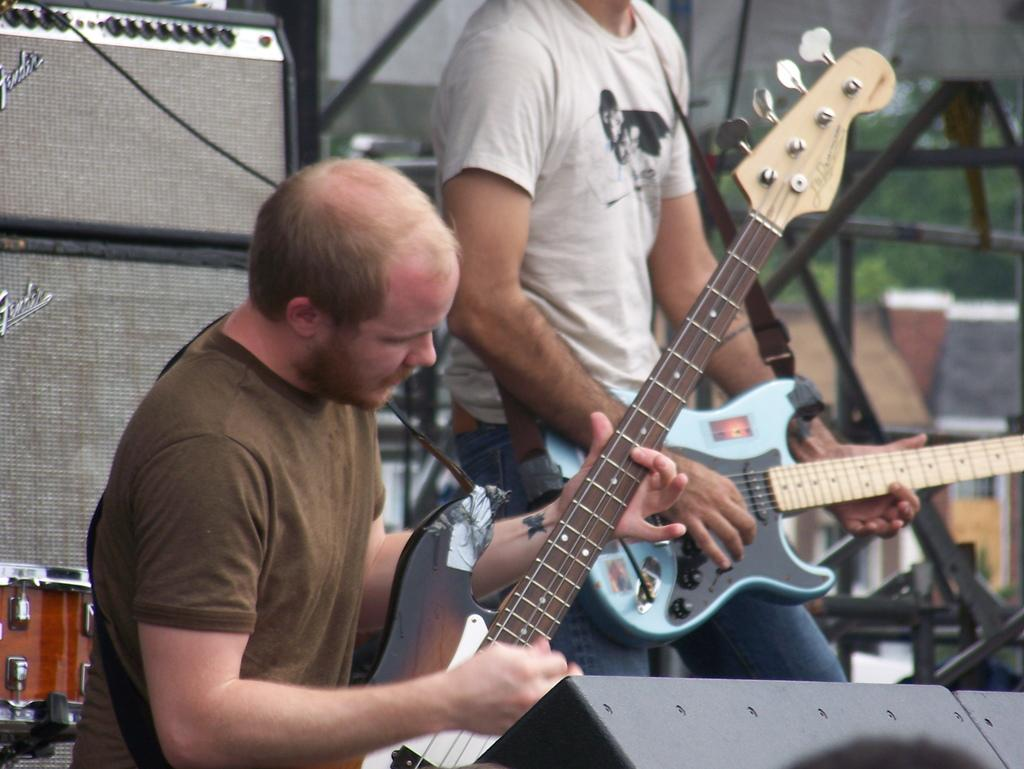How many people are in the image? There are two people in the image. What are the two people doing in the image? The two people are holding musical instruments. Can you describe the musical instrument in the background of the image? There is a musical instrument in the background of the image, but its specific details are not clear from the provided facts. What other object can be seen in the background of the image? There is a speaker in the background of the image. What type of calendar is hanging on the wall in the image? There is no calendar present in the image. How many chairs are visible in the image? There is no mention of chairs in the provided facts, so we cannot determine the number of chairs in the image. 